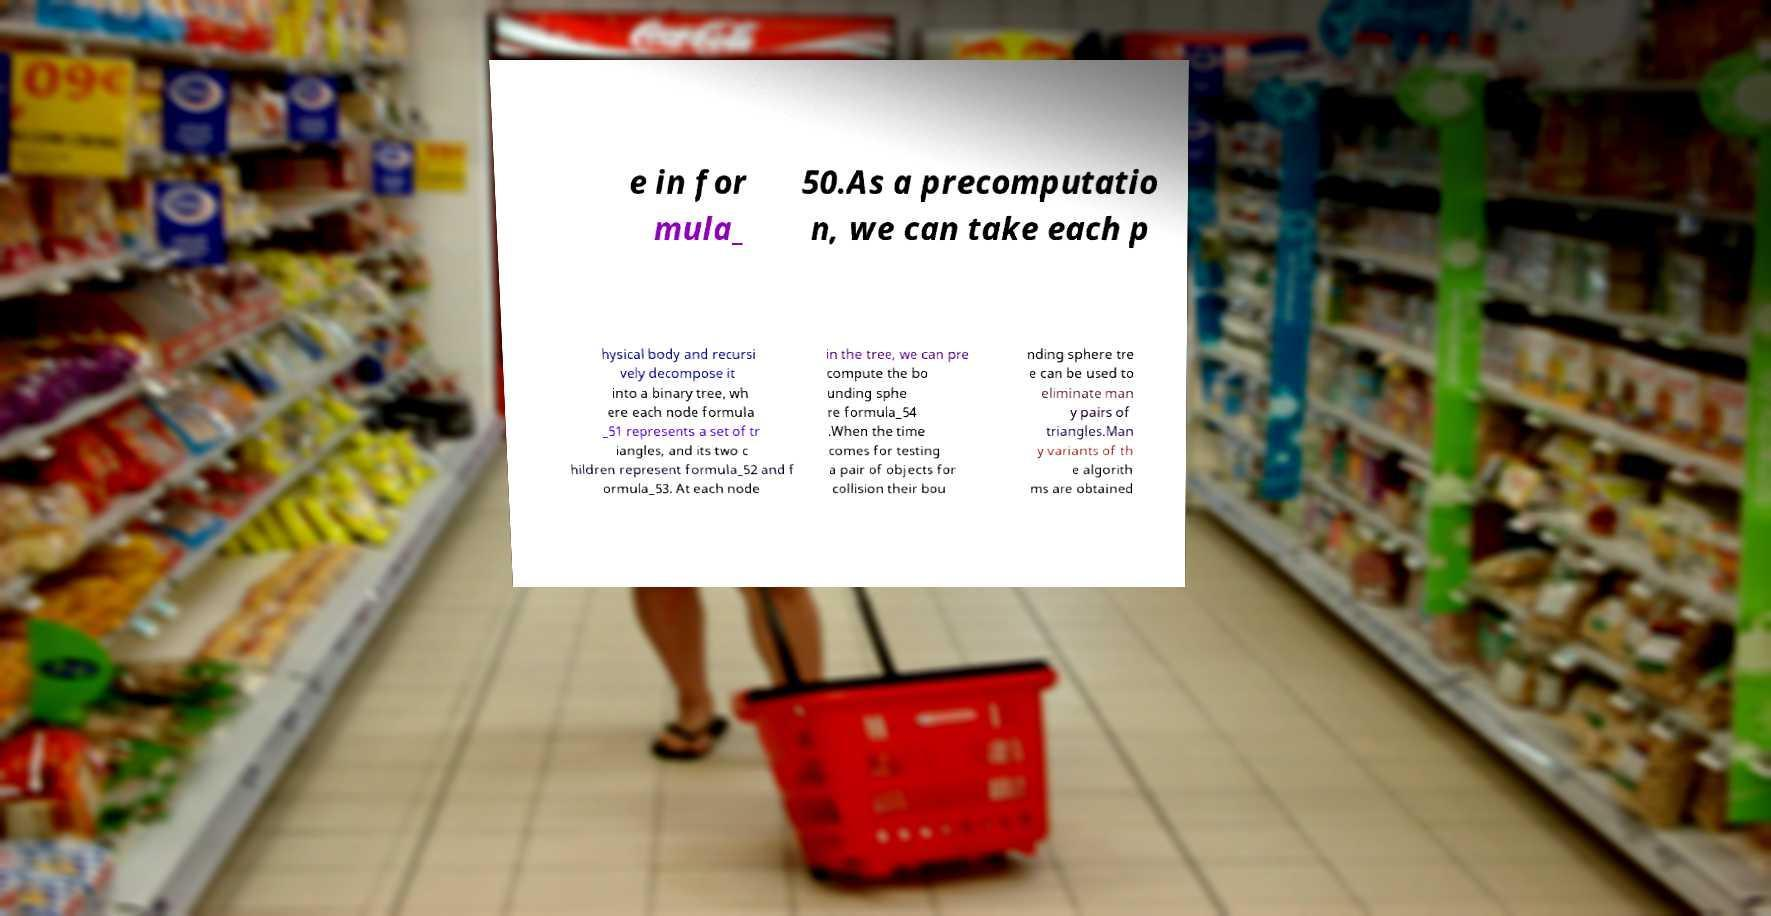What messages or text are displayed in this image? I need them in a readable, typed format. e in for mula_ 50.As a precomputatio n, we can take each p hysical body and recursi vely decompose it into a binary tree, wh ere each node formula _51 represents a set of tr iangles, and its two c hildren represent formula_52 and f ormula_53. At each node in the tree, we can pre compute the bo unding sphe re formula_54 .When the time comes for testing a pair of objects for collision their bou nding sphere tre e can be used to eliminate man y pairs of triangles.Man y variants of th e algorith ms are obtained 